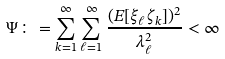<formula> <loc_0><loc_0><loc_500><loc_500>\Psi \colon = \sum _ { k = 1 } ^ { \infty } \sum _ { \ell = 1 } ^ { \infty } \frac { ( E [ \xi _ { \ell } \zeta _ { k } ] ) ^ { 2 } } { \lambda _ { \ell } ^ { 2 } } < \infty</formula> 